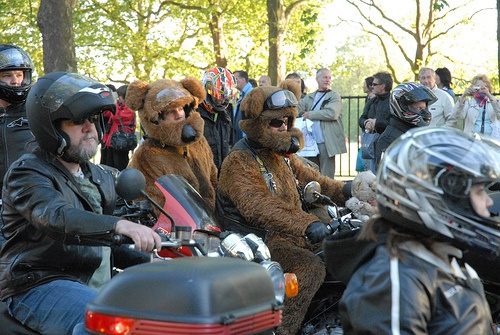Describe the objects in this image and their specific colors. I can see people in olive, black, blue, and gray tones, people in olive, black, gray, darkgray, and blue tones, people in olive, black, maroon, and gray tones, motorcycle in olive, gray, and blue tones, and people in olive, maroon, and gray tones in this image. 